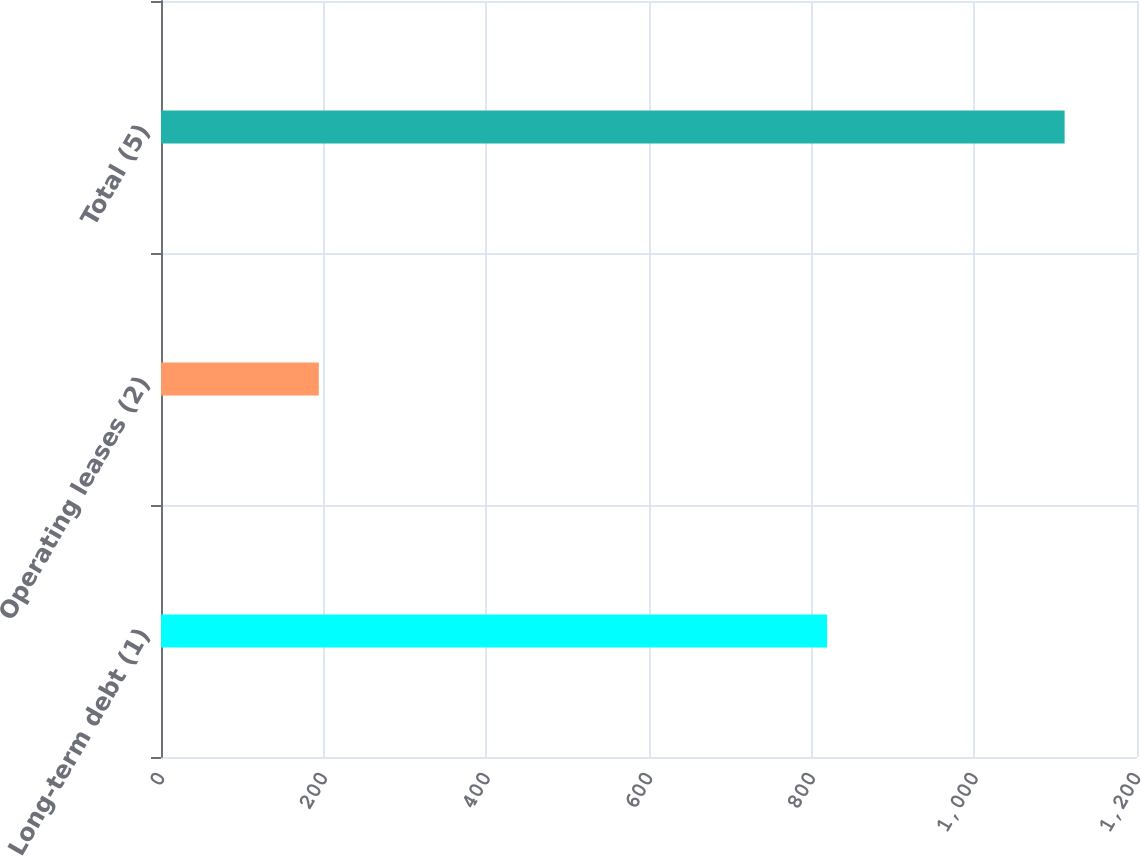<chart> <loc_0><loc_0><loc_500><loc_500><bar_chart><fcel>Long-term debt (1)<fcel>Operating leases (2)<fcel>Total (5)<nl><fcel>819<fcel>194<fcel>1111<nl></chart> 